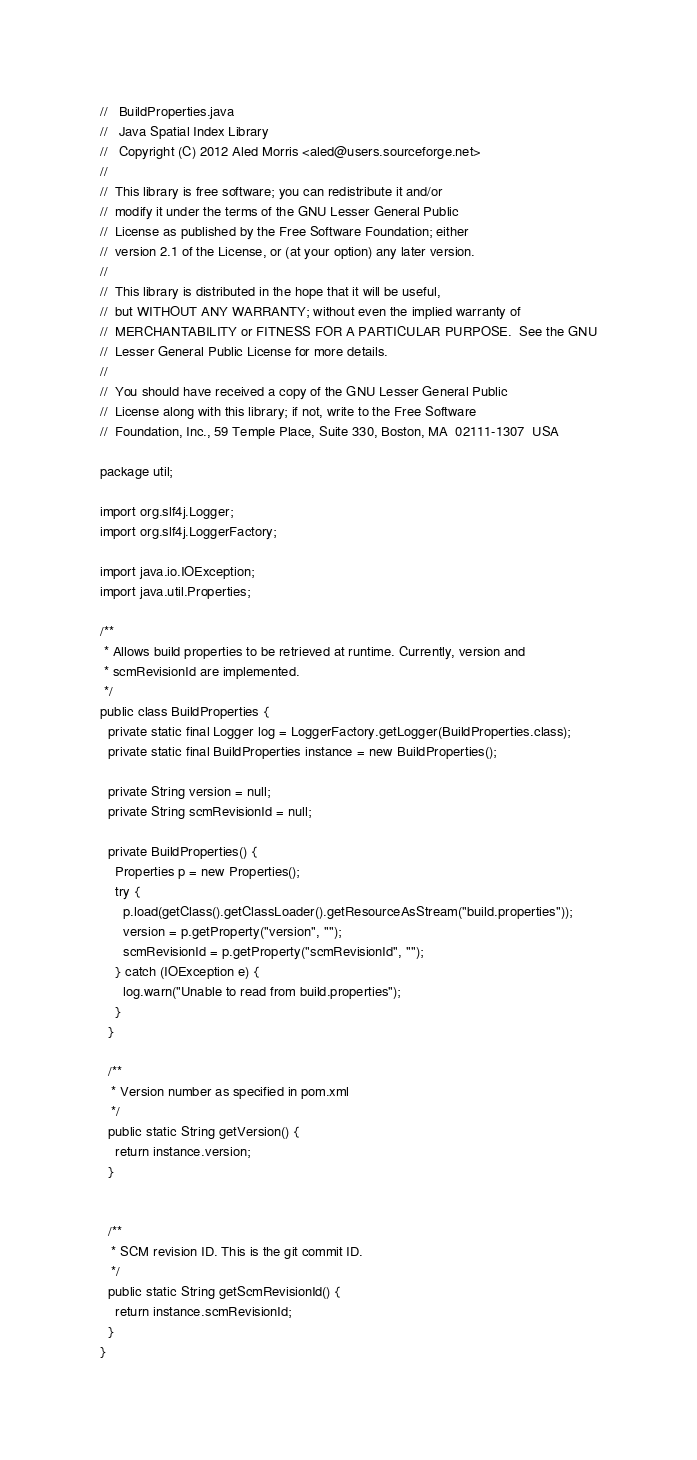<code> <loc_0><loc_0><loc_500><loc_500><_Java_>//   BuildProperties.java
//   Java Spatial Index Library
//   Copyright (C) 2012 Aled Morris <aled@users.sourceforge.net>
//  
//  This library is free software; you can redistribute it and/or
//  modify it under the terms of the GNU Lesser General Public
//  License as published by the Free Software Foundation; either
//  version 2.1 of the License, or (at your option) any later version.
//  
//  This library is distributed in the hope that it will be useful,
//  but WITHOUT ANY WARRANTY; without even the implied warranty of
//  MERCHANTABILITY or FITNESS FOR A PARTICULAR PURPOSE.  See the GNU
//  Lesser General Public License for more details.
//  
//  You should have received a copy of the GNU Lesser General Public
//  License along with this library; if not, write to the Free Software
//  Foundation, Inc., 59 Temple Place, Suite 330, Boston, MA  02111-1307  USA

package util;

import org.slf4j.Logger;
import org.slf4j.LoggerFactory;

import java.io.IOException;
import java.util.Properties;

/**
 * Allows build properties to be retrieved at runtime. Currently, version and
 * scmRevisionId are implemented.
 */
public class BuildProperties {
  private static final Logger log = LoggerFactory.getLogger(BuildProperties.class);
  private static final BuildProperties instance = new BuildProperties();
  
  private String version = null;
  private String scmRevisionId = null;
  
  private BuildProperties() {
    Properties p = new Properties();
    try {
      p.load(getClass().getClassLoader().getResourceAsStream("build.properties"));
      version = p.getProperty("version", "");
      scmRevisionId = p.getProperty("scmRevisionId", "");
    } catch (IOException e) {
      log.warn("Unable to read from build.properties");
    }
  }
  
  /**
   * Version number as specified in pom.xml
   */
  public static String getVersion() {
    return instance.version;
  }
  
  
  /**
   * SCM revision ID. This is the git commit ID.
   */
  public static String getScmRevisionId() {
    return instance.scmRevisionId;
  }
}
</code> 